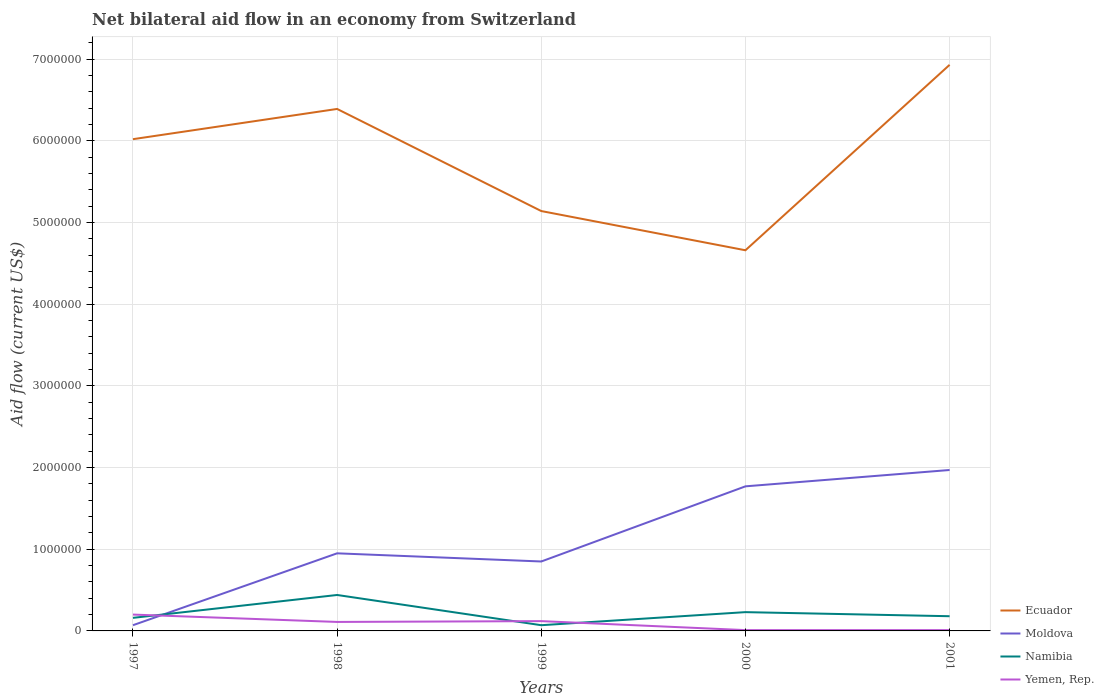How many different coloured lines are there?
Your answer should be very brief. 4. Does the line corresponding to Moldova intersect with the line corresponding to Namibia?
Keep it short and to the point. Yes. Is the number of lines equal to the number of legend labels?
Keep it short and to the point. Yes. Across all years, what is the maximum net bilateral aid flow in Ecuador?
Ensure brevity in your answer.  4.66e+06. In which year was the net bilateral aid flow in Ecuador maximum?
Offer a very short reply. 2000. What is the total net bilateral aid flow in Ecuador in the graph?
Make the answer very short. -5.40e+05. How many years are there in the graph?
Your answer should be very brief. 5. What is the difference between two consecutive major ticks on the Y-axis?
Give a very brief answer. 1.00e+06. Are the values on the major ticks of Y-axis written in scientific E-notation?
Ensure brevity in your answer.  No. How many legend labels are there?
Keep it short and to the point. 4. How are the legend labels stacked?
Your answer should be compact. Vertical. What is the title of the graph?
Ensure brevity in your answer.  Net bilateral aid flow in an economy from Switzerland. Does "Senegal" appear as one of the legend labels in the graph?
Your answer should be very brief. No. What is the Aid flow (current US$) in Ecuador in 1997?
Offer a very short reply. 6.02e+06. What is the Aid flow (current US$) in Yemen, Rep. in 1997?
Provide a succinct answer. 2.00e+05. What is the Aid flow (current US$) in Ecuador in 1998?
Your answer should be very brief. 6.39e+06. What is the Aid flow (current US$) of Moldova in 1998?
Give a very brief answer. 9.50e+05. What is the Aid flow (current US$) in Ecuador in 1999?
Your answer should be compact. 5.14e+06. What is the Aid flow (current US$) in Moldova in 1999?
Give a very brief answer. 8.50e+05. What is the Aid flow (current US$) of Namibia in 1999?
Offer a terse response. 7.00e+04. What is the Aid flow (current US$) in Ecuador in 2000?
Make the answer very short. 4.66e+06. What is the Aid flow (current US$) in Moldova in 2000?
Your answer should be compact. 1.77e+06. What is the Aid flow (current US$) of Yemen, Rep. in 2000?
Keep it short and to the point. 10000. What is the Aid flow (current US$) of Ecuador in 2001?
Ensure brevity in your answer.  6.93e+06. What is the Aid flow (current US$) of Moldova in 2001?
Offer a very short reply. 1.97e+06. What is the Aid flow (current US$) in Yemen, Rep. in 2001?
Provide a short and direct response. 10000. Across all years, what is the maximum Aid flow (current US$) in Ecuador?
Offer a terse response. 6.93e+06. Across all years, what is the maximum Aid flow (current US$) in Moldova?
Your response must be concise. 1.97e+06. Across all years, what is the maximum Aid flow (current US$) of Yemen, Rep.?
Provide a short and direct response. 2.00e+05. Across all years, what is the minimum Aid flow (current US$) in Ecuador?
Give a very brief answer. 4.66e+06. Across all years, what is the minimum Aid flow (current US$) of Moldova?
Make the answer very short. 7.00e+04. What is the total Aid flow (current US$) in Ecuador in the graph?
Offer a terse response. 2.91e+07. What is the total Aid flow (current US$) in Moldova in the graph?
Keep it short and to the point. 5.61e+06. What is the total Aid flow (current US$) of Namibia in the graph?
Your response must be concise. 1.08e+06. What is the total Aid flow (current US$) of Yemen, Rep. in the graph?
Your response must be concise. 4.50e+05. What is the difference between the Aid flow (current US$) in Ecuador in 1997 and that in 1998?
Your answer should be compact. -3.70e+05. What is the difference between the Aid flow (current US$) in Moldova in 1997 and that in 1998?
Your answer should be very brief. -8.80e+05. What is the difference between the Aid flow (current US$) in Namibia in 1997 and that in 1998?
Offer a very short reply. -2.80e+05. What is the difference between the Aid flow (current US$) in Yemen, Rep. in 1997 and that in 1998?
Make the answer very short. 9.00e+04. What is the difference between the Aid flow (current US$) in Ecuador in 1997 and that in 1999?
Keep it short and to the point. 8.80e+05. What is the difference between the Aid flow (current US$) of Moldova in 1997 and that in 1999?
Make the answer very short. -7.80e+05. What is the difference between the Aid flow (current US$) of Yemen, Rep. in 1997 and that in 1999?
Provide a short and direct response. 8.00e+04. What is the difference between the Aid flow (current US$) in Ecuador in 1997 and that in 2000?
Your answer should be compact. 1.36e+06. What is the difference between the Aid flow (current US$) of Moldova in 1997 and that in 2000?
Offer a terse response. -1.70e+06. What is the difference between the Aid flow (current US$) in Namibia in 1997 and that in 2000?
Your answer should be very brief. -7.00e+04. What is the difference between the Aid flow (current US$) in Yemen, Rep. in 1997 and that in 2000?
Your response must be concise. 1.90e+05. What is the difference between the Aid flow (current US$) of Ecuador in 1997 and that in 2001?
Your response must be concise. -9.10e+05. What is the difference between the Aid flow (current US$) of Moldova in 1997 and that in 2001?
Keep it short and to the point. -1.90e+06. What is the difference between the Aid flow (current US$) in Ecuador in 1998 and that in 1999?
Your response must be concise. 1.25e+06. What is the difference between the Aid flow (current US$) in Moldova in 1998 and that in 1999?
Your answer should be compact. 1.00e+05. What is the difference between the Aid flow (current US$) in Namibia in 1998 and that in 1999?
Give a very brief answer. 3.70e+05. What is the difference between the Aid flow (current US$) of Ecuador in 1998 and that in 2000?
Provide a short and direct response. 1.73e+06. What is the difference between the Aid flow (current US$) in Moldova in 1998 and that in 2000?
Offer a terse response. -8.20e+05. What is the difference between the Aid flow (current US$) of Namibia in 1998 and that in 2000?
Offer a very short reply. 2.10e+05. What is the difference between the Aid flow (current US$) in Ecuador in 1998 and that in 2001?
Offer a terse response. -5.40e+05. What is the difference between the Aid flow (current US$) in Moldova in 1998 and that in 2001?
Ensure brevity in your answer.  -1.02e+06. What is the difference between the Aid flow (current US$) in Yemen, Rep. in 1998 and that in 2001?
Give a very brief answer. 1.00e+05. What is the difference between the Aid flow (current US$) in Ecuador in 1999 and that in 2000?
Your answer should be compact. 4.80e+05. What is the difference between the Aid flow (current US$) of Moldova in 1999 and that in 2000?
Make the answer very short. -9.20e+05. What is the difference between the Aid flow (current US$) in Ecuador in 1999 and that in 2001?
Keep it short and to the point. -1.79e+06. What is the difference between the Aid flow (current US$) of Moldova in 1999 and that in 2001?
Offer a terse response. -1.12e+06. What is the difference between the Aid flow (current US$) of Ecuador in 2000 and that in 2001?
Your response must be concise. -2.27e+06. What is the difference between the Aid flow (current US$) in Moldova in 2000 and that in 2001?
Ensure brevity in your answer.  -2.00e+05. What is the difference between the Aid flow (current US$) in Yemen, Rep. in 2000 and that in 2001?
Ensure brevity in your answer.  0. What is the difference between the Aid flow (current US$) of Ecuador in 1997 and the Aid flow (current US$) of Moldova in 1998?
Offer a very short reply. 5.07e+06. What is the difference between the Aid flow (current US$) of Ecuador in 1997 and the Aid flow (current US$) of Namibia in 1998?
Make the answer very short. 5.58e+06. What is the difference between the Aid flow (current US$) in Ecuador in 1997 and the Aid flow (current US$) in Yemen, Rep. in 1998?
Keep it short and to the point. 5.91e+06. What is the difference between the Aid flow (current US$) in Moldova in 1997 and the Aid flow (current US$) in Namibia in 1998?
Offer a very short reply. -3.70e+05. What is the difference between the Aid flow (current US$) in Namibia in 1997 and the Aid flow (current US$) in Yemen, Rep. in 1998?
Offer a terse response. 5.00e+04. What is the difference between the Aid flow (current US$) of Ecuador in 1997 and the Aid flow (current US$) of Moldova in 1999?
Your answer should be compact. 5.17e+06. What is the difference between the Aid flow (current US$) in Ecuador in 1997 and the Aid flow (current US$) in Namibia in 1999?
Your response must be concise. 5.95e+06. What is the difference between the Aid flow (current US$) in Ecuador in 1997 and the Aid flow (current US$) in Yemen, Rep. in 1999?
Ensure brevity in your answer.  5.90e+06. What is the difference between the Aid flow (current US$) in Moldova in 1997 and the Aid flow (current US$) in Namibia in 1999?
Keep it short and to the point. 0. What is the difference between the Aid flow (current US$) in Moldova in 1997 and the Aid flow (current US$) in Yemen, Rep. in 1999?
Make the answer very short. -5.00e+04. What is the difference between the Aid flow (current US$) in Ecuador in 1997 and the Aid flow (current US$) in Moldova in 2000?
Ensure brevity in your answer.  4.25e+06. What is the difference between the Aid flow (current US$) in Ecuador in 1997 and the Aid flow (current US$) in Namibia in 2000?
Keep it short and to the point. 5.79e+06. What is the difference between the Aid flow (current US$) of Ecuador in 1997 and the Aid flow (current US$) of Yemen, Rep. in 2000?
Offer a very short reply. 6.01e+06. What is the difference between the Aid flow (current US$) of Moldova in 1997 and the Aid flow (current US$) of Yemen, Rep. in 2000?
Keep it short and to the point. 6.00e+04. What is the difference between the Aid flow (current US$) in Namibia in 1997 and the Aid flow (current US$) in Yemen, Rep. in 2000?
Give a very brief answer. 1.50e+05. What is the difference between the Aid flow (current US$) in Ecuador in 1997 and the Aid flow (current US$) in Moldova in 2001?
Make the answer very short. 4.05e+06. What is the difference between the Aid flow (current US$) in Ecuador in 1997 and the Aid flow (current US$) in Namibia in 2001?
Ensure brevity in your answer.  5.84e+06. What is the difference between the Aid flow (current US$) in Ecuador in 1997 and the Aid flow (current US$) in Yemen, Rep. in 2001?
Provide a short and direct response. 6.01e+06. What is the difference between the Aid flow (current US$) in Moldova in 1997 and the Aid flow (current US$) in Namibia in 2001?
Your answer should be very brief. -1.10e+05. What is the difference between the Aid flow (current US$) of Namibia in 1997 and the Aid flow (current US$) of Yemen, Rep. in 2001?
Provide a succinct answer. 1.50e+05. What is the difference between the Aid flow (current US$) of Ecuador in 1998 and the Aid flow (current US$) of Moldova in 1999?
Offer a very short reply. 5.54e+06. What is the difference between the Aid flow (current US$) in Ecuador in 1998 and the Aid flow (current US$) in Namibia in 1999?
Your response must be concise. 6.32e+06. What is the difference between the Aid flow (current US$) in Ecuador in 1998 and the Aid flow (current US$) in Yemen, Rep. in 1999?
Provide a succinct answer. 6.27e+06. What is the difference between the Aid flow (current US$) in Moldova in 1998 and the Aid flow (current US$) in Namibia in 1999?
Keep it short and to the point. 8.80e+05. What is the difference between the Aid flow (current US$) in Moldova in 1998 and the Aid flow (current US$) in Yemen, Rep. in 1999?
Provide a succinct answer. 8.30e+05. What is the difference between the Aid flow (current US$) in Ecuador in 1998 and the Aid flow (current US$) in Moldova in 2000?
Make the answer very short. 4.62e+06. What is the difference between the Aid flow (current US$) of Ecuador in 1998 and the Aid flow (current US$) of Namibia in 2000?
Ensure brevity in your answer.  6.16e+06. What is the difference between the Aid flow (current US$) of Ecuador in 1998 and the Aid flow (current US$) of Yemen, Rep. in 2000?
Make the answer very short. 6.38e+06. What is the difference between the Aid flow (current US$) of Moldova in 1998 and the Aid flow (current US$) of Namibia in 2000?
Offer a very short reply. 7.20e+05. What is the difference between the Aid flow (current US$) of Moldova in 1998 and the Aid flow (current US$) of Yemen, Rep. in 2000?
Keep it short and to the point. 9.40e+05. What is the difference between the Aid flow (current US$) of Ecuador in 1998 and the Aid flow (current US$) of Moldova in 2001?
Give a very brief answer. 4.42e+06. What is the difference between the Aid flow (current US$) in Ecuador in 1998 and the Aid flow (current US$) in Namibia in 2001?
Offer a very short reply. 6.21e+06. What is the difference between the Aid flow (current US$) in Ecuador in 1998 and the Aid flow (current US$) in Yemen, Rep. in 2001?
Make the answer very short. 6.38e+06. What is the difference between the Aid flow (current US$) of Moldova in 1998 and the Aid flow (current US$) of Namibia in 2001?
Your response must be concise. 7.70e+05. What is the difference between the Aid flow (current US$) in Moldova in 1998 and the Aid flow (current US$) in Yemen, Rep. in 2001?
Your answer should be very brief. 9.40e+05. What is the difference between the Aid flow (current US$) of Ecuador in 1999 and the Aid flow (current US$) of Moldova in 2000?
Keep it short and to the point. 3.37e+06. What is the difference between the Aid flow (current US$) of Ecuador in 1999 and the Aid flow (current US$) of Namibia in 2000?
Provide a succinct answer. 4.91e+06. What is the difference between the Aid flow (current US$) in Ecuador in 1999 and the Aid flow (current US$) in Yemen, Rep. in 2000?
Keep it short and to the point. 5.13e+06. What is the difference between the Aid flow (current US$) of Moldova in 1999 and the Aid flow (current US$) of Namibia in 2000?
Your answer should be compact. 6.20e+05. What is the difference between the Aid flow (current US$) of Moldova in 1999 and the Aid flow (current US$) of Yemen, Rep. in 2000?
Offer a very short reply. 8.40e+05. What is the difference between the Aid flow (current US$) of Ecuador in 1999 and the Aid flow (current US$) of Moldova in 2001?
Provide a succinct answer. 3.17e+06. What is the difference between the Aid flow (current US$) in Ecuador in 1999 and the Aid flow (current US$) in Namibia in 2001?
Offer a very short reply. 4.96e+06. What is the difference between the Aid flow (current US$) in Ecuador in 1999 and the Aid flow (current US$) in Yemen, Rep. in 2001?
Keep it short and to the point. 5.13e+06. What is the difference between the Aid flow (current US$) of Moldova in 1999 and the Aid flow (current US$) of Namibia in 2001?
Provide a succinct answer. 6.70e+05. What is the difference between the Aid flow (current US$) of Moldova in 1999 and the Aid flow (current US$) of Yemen, Rep. in 2001?
Provide a short and direct response. 8.40e+05. What is the difference between the Aid flow (current US$) in Namibia in 1999 and the Aid flow (current US$) in Yemen, Rep. in 2001?
Provide a succinct answer. 6.00e+04. What is the difference between the Aid flow (current US$) of Ecuador in 2000 and the Aid flow (current US$) of Moldova in 2001?
Offer a terse response. 2.69e+06. What is the difference between the Aid flow (current US$) of Ecuador in 2000 and the Aid flow (current US$) of Namibia in 2001?
Make the answer very short. 4.48e+06. What is the difference between the Aid flow (current US$) of Ecuador in 2000 and the Aid flow (current US$) of Yemen, Rep. in 2001?
Keep it short and to the point. 4.65e+06. What is the difference between the Aid flow (current US$) of Moldova in 2000 and the Aid flow (current US$) of Namibia in 2001?
Your answer should be very brief. 1.59e+06. What is the difference between the Aid flow (current US$) of Moldova in 2000 and the Aid flow (current US$) of Yemen, Rep. in 2001?
Offer a terse response. 1.76e+06. What is the average Aid flow (current US$) in Ecuador per year?
Your response must be concise. 5.83e+06. What is the average Aid flow (current US$) of Moldova per year?
Provide a succinct answer. 1.12e+06. What is the average Aid flow (current US$) of Namibia per year?
Ensure brevity in your answer.  2.16e+05. In the year 1997, what is the difference between the Aid flow (current US$) in Ecuador and Aid flow (current US$) in Moldova?
Offer a very short reply. 5.95e+06. In the year 1997, what is the difference between the Aid flow (current US$) of Ecuador and Aid flow (current US$) of Namibia?
Your answer should be compact. 5.86e+06. In the year 1997, what is the difference between the Aid flow (current US$) of Ecuador and Aid flow (current US$) of Yemen, Rep.?
Keep it short and to the point. 5.82e+06. In the year 1997, what is the difference between the Aid flow (current US$) in Namibia and Aid flow (current US$) in Yemen, Rep.?
Give a very brief answer. -4.00e+04. In the year 1998, what is the difference between the Aid flow (current US$) in Ecuador and Aid flow (current US$) in Moldova?
Offer a terse response. 5.44e+06. In the year 1998, what is the difference between the Aid flow (current US$) in Ecuador and Aid flow (current US$) in Namibia?
Your answer should be very brief. 5.95e+06. In the year 1998, what is the difference between the Aid flow (current US$) in Ecuador and Aid flow (current US$) in Yemen, Rep.?
Give a very brief answer. 6.28e+06. In the year 1998, what is the difference between the Aid flow (current US$) in Moldova and Aid flow (current US$) in Namibia?
Offer a terse response. 5.10e+05. In the year 1998, what is the difference between the Aid flow (current US$) of Moldova and Aid flow (current US$) of Yemen, Rep.?
Ensure brevity in your answer.  8.40e+05. In the year 1998, what is the difference between the Aid flow (current US$) of Namibia and Aid flow (current US$) of Yemen, Rep.?
Your answer should be very brief. 3.30e+05. In the year 1999, what is the difference between the Aid flow (current US$) in Ecuador and Aid flow (current US$) in Moldova?
Your response must be concise. 4.29e+06. In the year 1999, what is the difference between the Aid flow (current US$) in Ecuador and Aid flow (current US$) in Namibia?
Ensure brevity in your answer.  5.07e+06. In the year 1999, what is the difference between the Aid flow (current US$) of Ecuador and Aid flow (current US$) of Yemen, Rep.?
Offer a terse response. 5.02e+06. In the year 1999, what is the difference between the Aid flow (current US$) of Moldova and Aid flow (current US$) of Namibia?
Provide a short and direct response. 7.80e+05. In the year 1999, what is the difference between the Aid flow (current US$) in Moldova and Aid flow (current US$) in Yemen, Rep.?
Your response must be concise. 7.30e+05. In the year 1999, what is the difference between the Aid flow (current US$) in Namibia and Aid flow (current US$) in Yemen, Rep.?
Offer a very short reply. -5.00e+04. In the year 2000, what is the difference between the Aid flow (current US$) in Ecuador and Aid flow (current US$) in Moldova?
Give a very brief answer. 2.89e+06. In the year 2000, what is the difference between the Aid flow (current US$) of Ecuador and Aid flow (current US$) of Namibia?
Offer a very short reply. 4.43e+06. In the year 2000, what is the difference between the Aid flow (current US$) in Ecuador and Aid flow (current US$) in Yemen, Rep.?
Keep it short and to the point. 4.65e+06. In the year 2000, what is the difference between the Aid flow (current US$) in Moldova and Aid flow (current US$) in Namibia?
Offer a terse response. 1.54e+06. In the year 2000, what is the difference between the Aid flow (current US$) of Moldova and Aid flow (current US$) of Yemen, Rep.?
Provide a succinct answer. 1.76e+06. In the year 2001, what is the difference between the Aid flow (current US$) of Ecuador and Aid flow (current US$) of Moldova?
Your response must be concise. 4.96e+06. In the year 2001, what is the difference between the Aid flow (current US$) in Ecuador and Aid flow (current US$) in Namibia?
Provide a succinct answer. 6.75e+06. In the year 2001, what is the difference between the Aid flow (current US$) in Ecuador and Aid flow (current US$) in Yemen, Rep.?
Your answer should be compact. 6.92e+06. In the year 2001, what is the difference between the Aid flow (current US$) of Moldova and Aid flow (current US$) of Namibia?
Keep it short and to the point. 1.79e+06. In the year 2001, what is the difference between the Aid flow (current US$) in Moldova and Aid flow (current US$) in Yemen, Rep.?
Provide a short and direct response. 1.96e+06. What is the ratio of the Aid flow (current US$) in Ecuador in 1997 to that in 1998?
Ensure brevity in your answer.  0.94. What is the ratio of the Aid flow (current US$) of Moldova in 1997 to that in 1998?
Your answer should be very brief. 0.07. What is the ratio of the Aid flow (current US$) of Namibia in 1997 to that in 1998?
Make the answer very short. 0.36. What is the ratio of the Aid flow (current US$) of Yemen, Rep. in 1997 to that in 1998?
Provide a succinct answer. 1.82. What is the ratio of the Aid flow (current US$) in Ecuador in 1997 to that in 1999?
Your answer should be compact. 1.17. What is the ratio of the Aid flow (current US$) of Moldova in 1997 to that in 1999?
Your answer should be very brief. 0.08. What is the ratio of the Aid flow (current US$) of Namibia in 1997 to that in 1999?
Keep it short and to the point. 2.29. What is the ratio of the Aid flow (current US$) of Yemen, Rep. in 1997 to that in 1999?
Your answer should be very brief. 1.67. What is the ratio of the Aid flow (current US$) of Ecuador in 1997 to that in 2000?
Keep it short and to the point. 1.29. What is the ratio of the Aid flow (current US$) in Moldova in 1997 to that in 2000?
Make the answer very short. 0.04. What is the ratio of the Aid flow (current US$) of Namibia in 1997 to that in 2000?
Keep it short and to the point. 0.7. What is the ratio of the Aid flow (current US$) in Yemen, Rep. in 1997 to that in 2000?
Give a very brief answer. 20. What is the ratio of the Aid flow (current US$) of Ecuador in 1997 to that in 2001?
Provide a short and direct response. 0.87. What is the ratio of the Aid flow (current US$) in Moldova in 1997 to that in 2001?
Keep it short and to the point. 0.04. What is the ratio of the Aid flow (current US$) in Yemen, Rep. in 1997 to that in 2001?
Make the answer very short. 20. What is the ratio of the Aid flow (current US$) of Ecuador in 1998 to that in 1999?
Offer a very short reply. 1.24. What is the ratio of the Aid flow (current US$) of Moldova in 1998 to that in 1999?
Your response must be concise. 1.12. What is the ratio of the Aid flow (current US$) in Namibia in 1998 to that in 1999?
Your answer should be compact. 6.29. What is the ratio of the Aid flow (current US$) in Ecuador in 1998 to that in 2000?
Your answer should be compact. 1.37. What is the ratio of the Aid flow (current US$) in Moldova in 1998 to that in 2000?
Your answer should be very brief. 0.54. What is the ratio of the Aid flow (current US$) in Namibia in 1998 to that in 2000?
Your response must be concise. 1.91. What is the ratio of the Aid flow (current US$) of Ecuador in 1998 to that in 2001?
Give a very brief answer. 0.92. What is the ratio of the Aid flow (current US$) of Moldova in 1998 to that in 2001?
Ensure brevity in your answer.  0.48. What is the ratio of the Aid flow (current US$) in Namibia in 1998 to that in 2001?
Ensure brevity in your answer.  2.44. What is the ratio of the Aid flow (current US$) of Ecuador in 1999 to that in 2000?
Provide a succinct answer. 1.1. What is the ratio of the Aid flow (current US$) in Moldova in 1999 to that in 2000?
Your response must be concise. 0.48. What is the ratio of the Aid flow (current US$) of Namibia in 1999 to that in 2000?
Offer a very short reply. 0.3. What is the ratio of the Aid flow (current US$) in Ecuador in 1999 to that in 2001?
Your answer should be very brief. 0.74. What is the ratio of the Aid flow (current US$) of Moldova in 1999 to that in 2001?
Ensure brevity in your answer.  0.43. What is the ratio of the Aid flow (current US$) of Namibia in 1999 to that in 2001?
Your response must be concise. 0.39. What is the ratio of the Aid flow (current US$) in Ecuador in 2000 to that in 2001?
Your answer should be compact. 0.67. What is the ratio of the Aid flow (current US$) in Moldova in 2000 to that in 2001?
Your answer should be compact. 0.9. What is the ratio of the Aid flow (current US$) in Namibia in 2000 to that in 2001?
Offer a very short reply. 1.28. What is the difference between the highest and the second highest Aid flow (current US$) in Ecuador?
Your answer should be very brief. 5.40e+05. What is the difference between the highest and the second highest Aid flow (current US$) of Yemen, Rep.?
Provide a short and direct response. 8.00e+04. What is the difference between the highest and the lowest Aid flow (current US$) in Ecuador?
Make the answer very short. 2.27e+06. What is the difference between the highest and the lowest Aid flow (current US$) of Moldova?
Keep it short and to the point. 1.90e+06. What is the difference between the highest and the lowest Aid flow (current US$) in Namibia?
Ensure brevity in your answer.  3.70e+05. What is the difference between the highest and the lowest Aid flow (current US$) of Yemen, Rep.?
Give a very brief answer. 1.90e+05. 